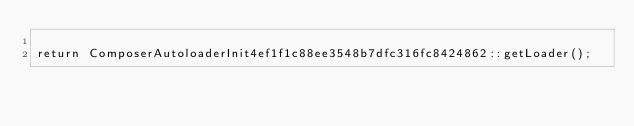Convert code to text. <code><loc_0><loc_0><loc_500><loc_500><_PHP_>
return ComposerAutoloaderInit4ef1f1c88ee3548b7dfc316fc8424862::getLoader();
</code> 